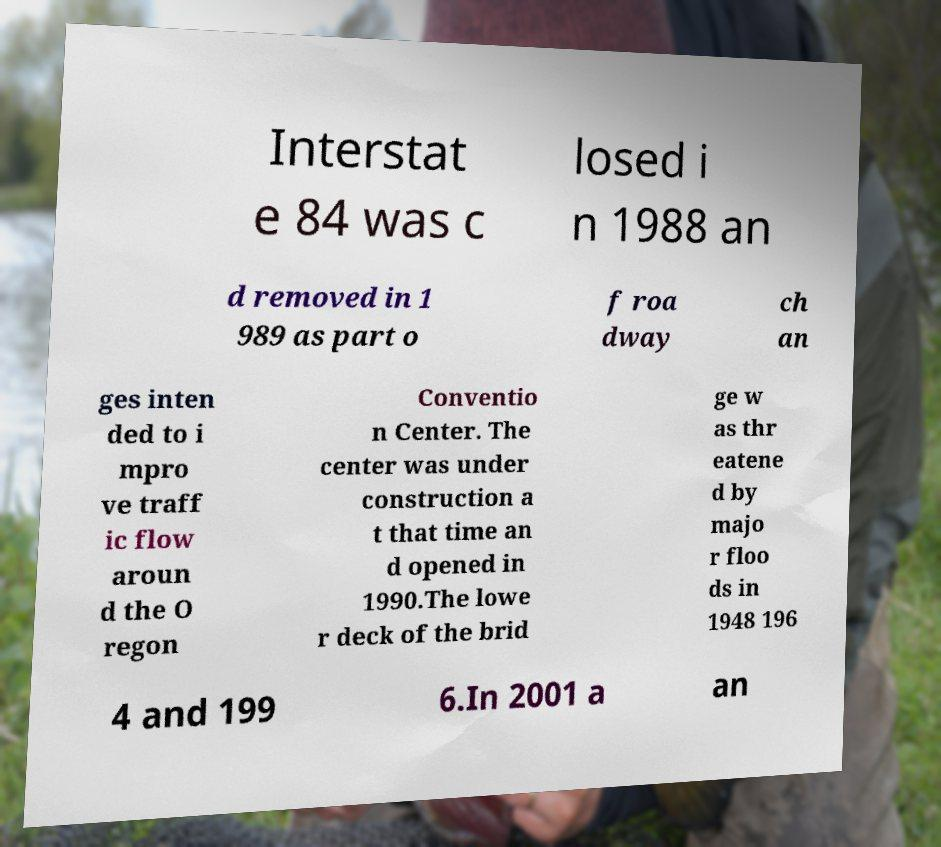Can you accurately transcribe the text from the provided image for me? Interstat e 84 was c losed i n 1988 an d removed in 1 989 as part o f roa dway ch an ges inten ded to i mpro ve traff ic flow aroun d the O regon Conventio n Center. The center was under construction a t that time an d opened in 1990.The lowe r deck of the brid ge w as thr eatene d by majo r floo ds in 1948 196 4 and 199 6.In 2001 a an 